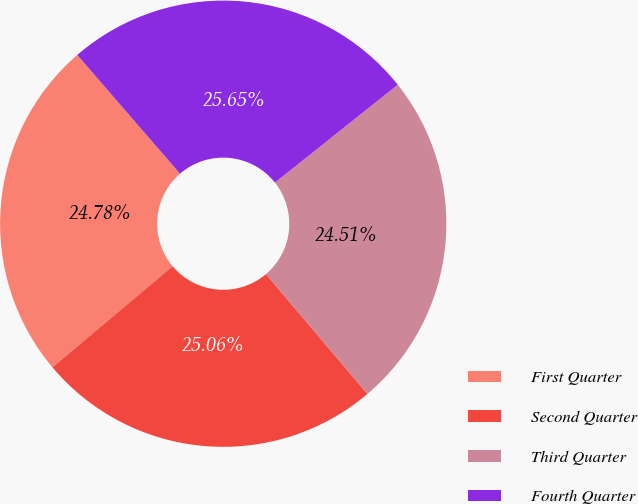<chart> <loc_0><loc_0><loc_500><loc_500><pie_chart><fcel>First Quarter<fcel>Second Quarter<fcel>Third Quarter<fcel>Fourth Quarter<nl><fcel>24.78%<fcel>25.06%<fcel>24.51%<fcel>25.65%<nl></chart> 